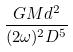<formula> <loc_0><loc_0><loc_500><loc_500>\frac { G M d ^ { 2 } } { ( 2 \omega ) ^ { 2 } D ^ { 5 } }</formula> 